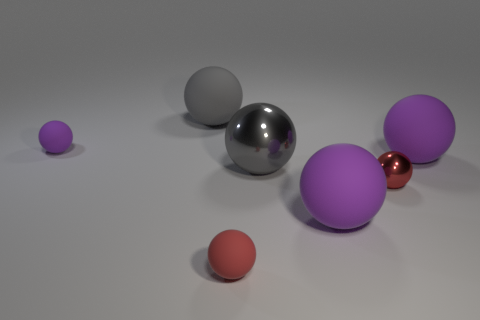The gray rubber thing that is the same shape as the small purple object is what size?
Offer a very short reply. Large. How many red objects are made of the same material as the tiny purple sphere?
Provide a short and direct response. 1. What number of things are either yellow metallic cylinders or purple balls?
Provide a short and direct response. 3. There is a shiny thing behind the red metal object; are there any purple objects that are behind it?
Provide a short and direct response. Yes. Is the number of large gray things that are left of the small purple matte thing greater than the number of rubber things that are in front of the red matte sphere?
Provide a short and direct response. No. There is another ball that is the same color as the large metal sphere; what is its material?
Your response must be concise. Rubber. How many small balls have the same color as the big shiny sphere?
Keep it short and to the point. 0. There is a large shiny sphere behind the tiny red rubber object; does it have the same color as the matte object that is left of the gray matte sphere?
Make the answer very short. No. There is a red rubber object; are there any small spheres behind it?
Offer a terse response. Yes. What is the small purple thing made of?
Offer a very short reply. Rubber. 